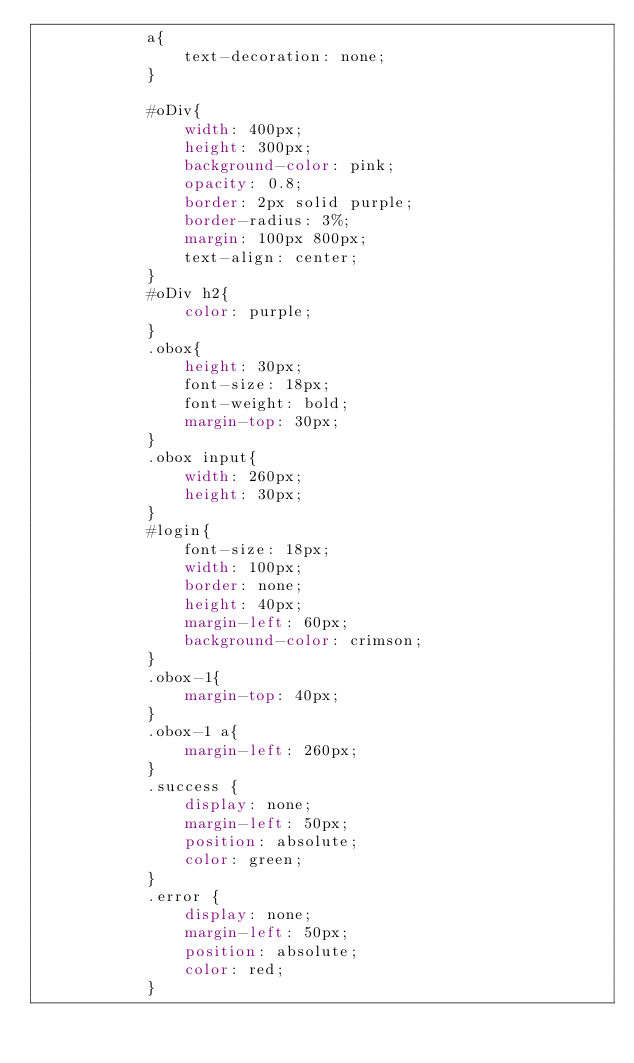Convert code to text. <code><loc_0><loc_0><loc_500><loc_500><_CSS_>            a{
            	text-decoration: none;
            }
           
            #oDiv{
		    	width: 400px;
		    	height: 300px;
		    	background-color: pink;
		    	opacity: 0.8;
		    	border: 2px solid purple;
		    	border-radius: 3%;
		    	margin: 100px 800px;
		    	text-align: center;
		    }
		    #oDiv h2{
		    	color: purple;
		    }
		    .obox{
		    	height: 30px;
		    	font-size: 18px;
		    	font-weight: bold;
		    	margin-top: 30px;
		    }
		    .obox input{
		    	width: 260px;
		    	height: 30px;
		    }
		    #login{
		    	font-size: 18px;
		    	width: 100px;
		    	border: none;
		    	height: 40px;
		    	margin-left: 60px;
		    	background-color: crimson;
		    }
		    .obox-1{
		    	margin-top: 40px;
		    }
		    .obox-1 a{
		    	margin-left: 260px;
		    }
			.success {
		        display: none;
		        margin-left: 50px;
		        position: absolute;
		        color: green;
		    }
		    .error {
		        display: none;
		        margin-left: 50px;
		        position: absolute;
		        color: red;
		    }</code> 